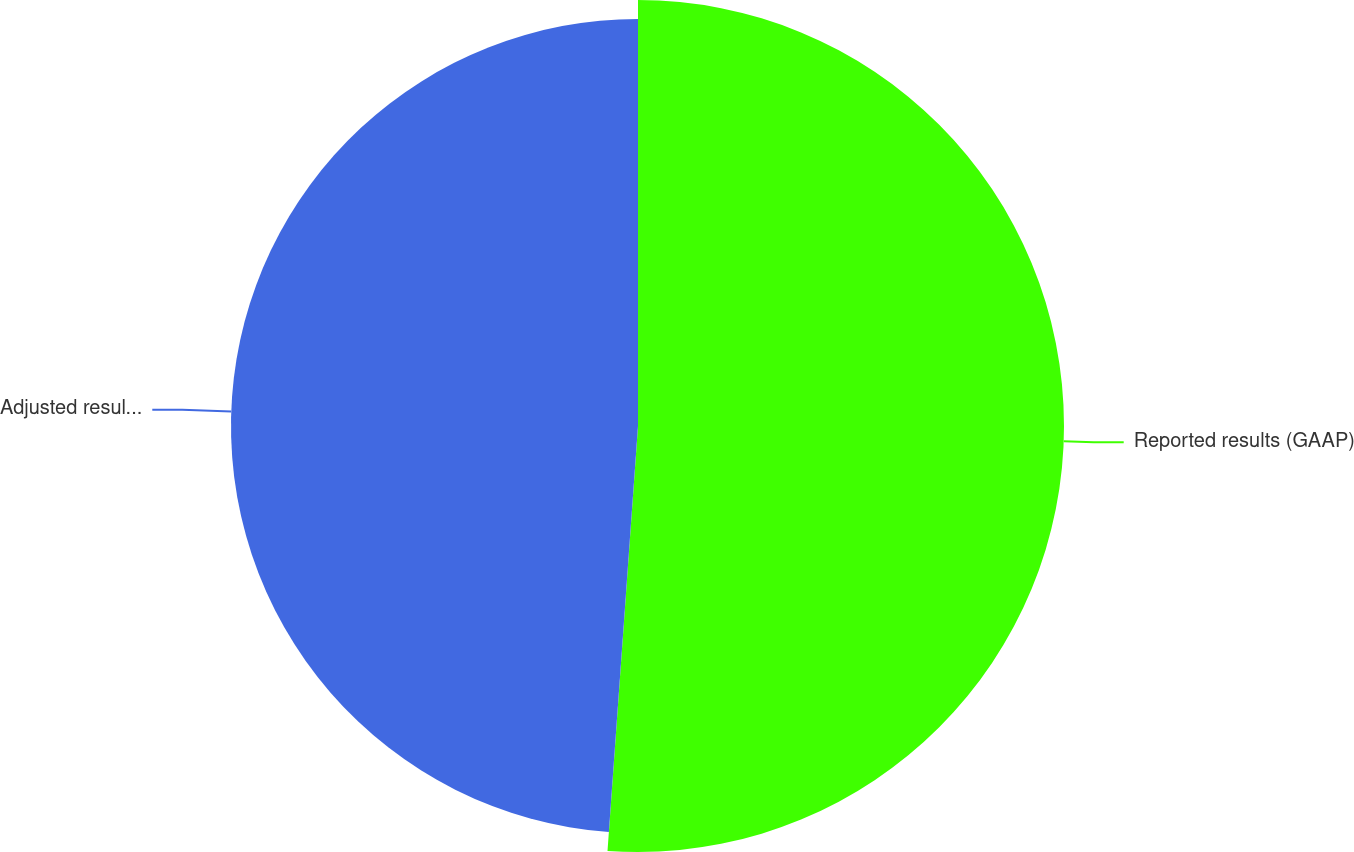<chart> <loc_0><loc_0><loc_500><loc_500><pie_chart><fcel>Reported results (GAAP)<fcel>Adjusted results (non-GAAP)<nl><fcel>51.14%<fcel>48.86%<nl></chart> 